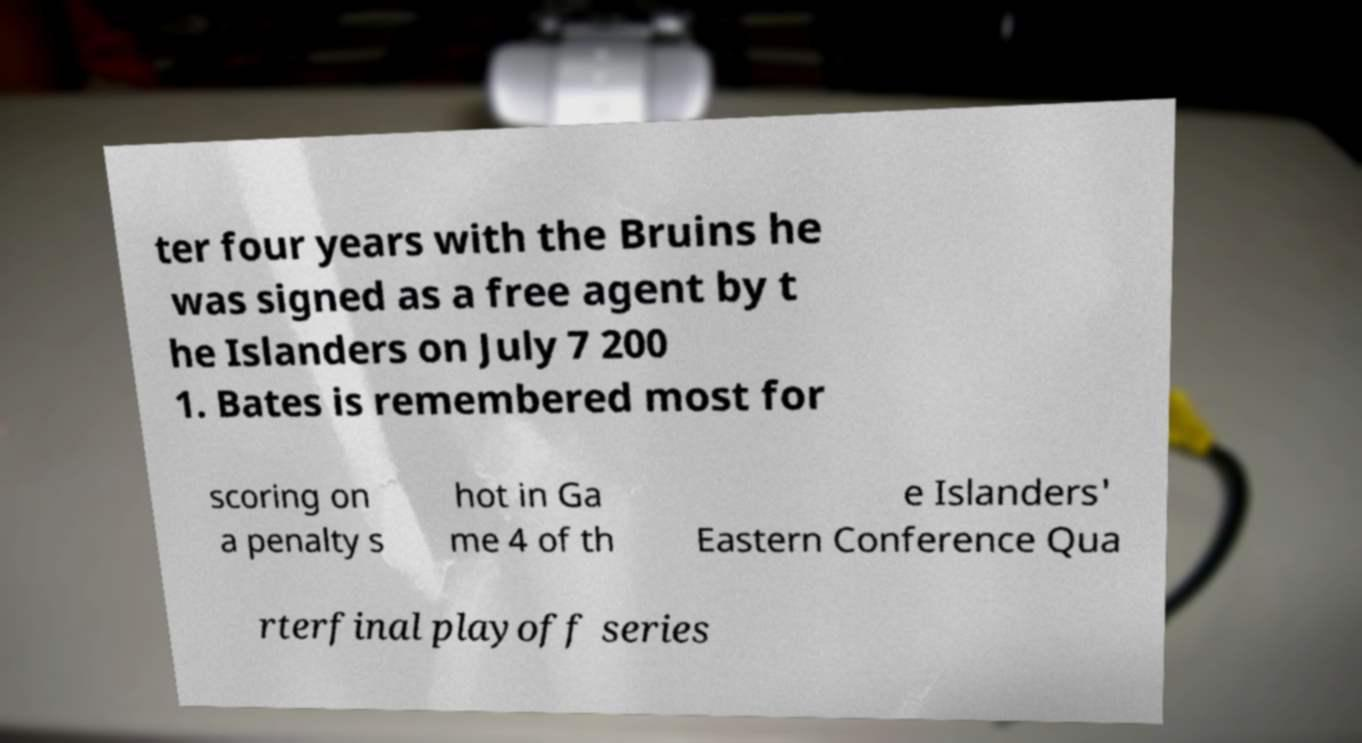Could you extract and type out the text from this image? ter four years with the Bruins he was signed as a free agent by t he Islanders on July 7 200 1. Bates is remembered most for scoring on a penalty s hot in Ga me 4 of th e Islanders' Eastern Conference Qua rterfinal playoff series 